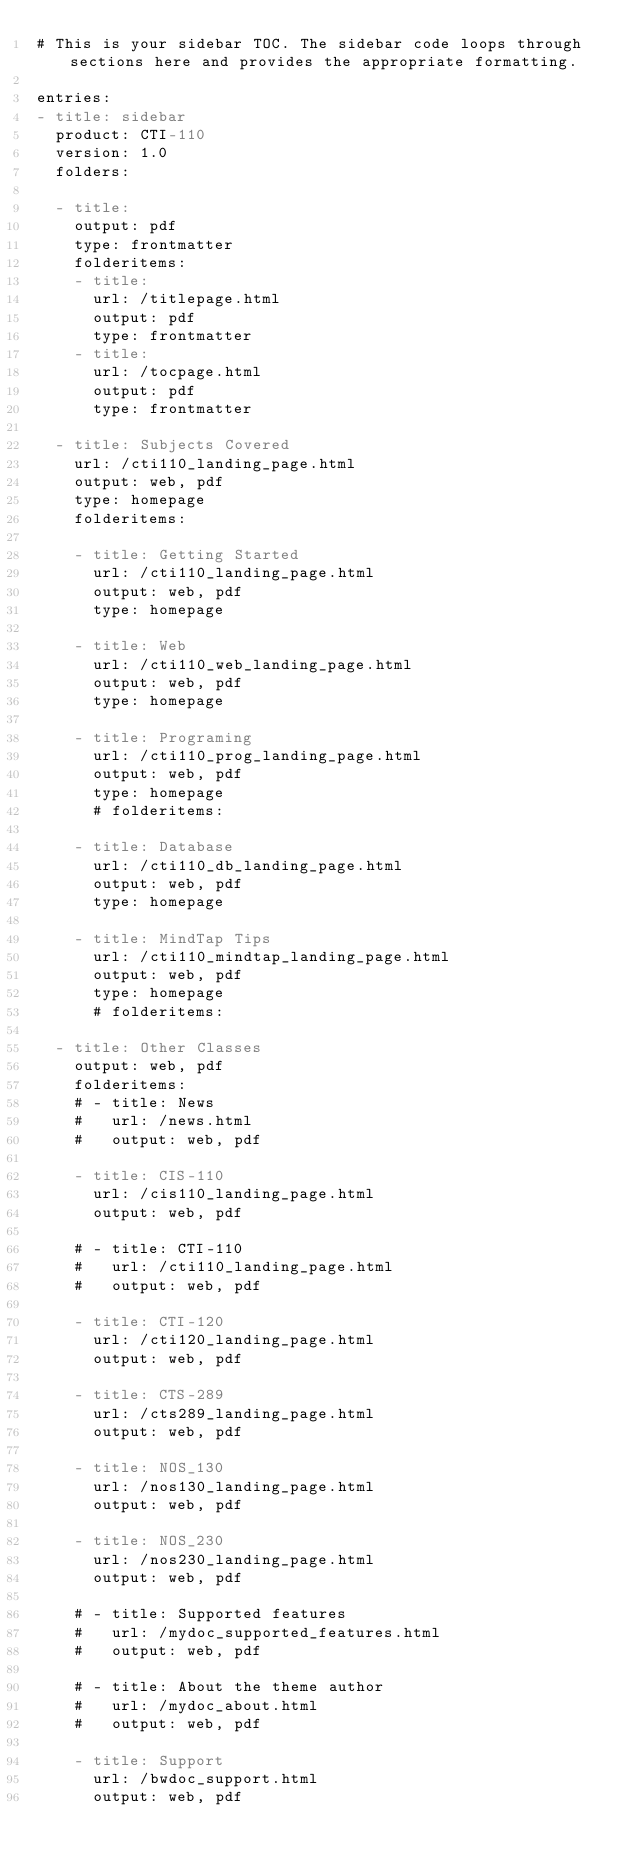Convert code to text. <code><loc_0><loc_0><loc_500><loc_500><_YAML_># This is your sidebar TOC. The sidebar code loops through sections here and provides the appropriate formatting.

entries:
- title: sidebar
  product: CTI-110
  version: 1.0
  folders:

  - title:
    output: pdf
    type: frontmatter
    folderitems:
    - title:
      url: /titlepage.html
      output: pdf
      type: frontmatter
    - title:
      url: /tocpage.html
      output: pdf
      type: frontmatter

  - title: Subjects Covered
    url: /cti110_landing_page.html
    output: web, pdf
    type: homepage
    folderitems:

    - title: Getting Started
      url: /cti110_landing_page.html
      output: web, pdf
      type: homepage

    - title: Web
      url: /cti110_web_landing_page.html
      output: web, pdf
      type: homepage

    - title: Programing
      url: /cti110_prog_landing_page.html
      output: web, pdf
      type: homepage
      # folderitems:

    - title: Database
      url: /cti110_db_landing_page.html
      output: web, pdf
      type: homepage

    - title: MindTap Tips
      url: /cti110_mindtap_landing_page.html
      output: web, pdf
      type: homepage
      # folderitems: 

  - title: Other Classes
    output: web, pdf
    folderitems:
    # - title: News
    #   url: /news.html
    #   output: web, pdf

    - title: CIS-110
      url: /cis110_landing_page.html
      output: web, pdf

    # - title: CTI-110
    #   url: /cti110_landing_page.html
    #   output: web, pdf

    - title: CTI-120
      url: /cti120_landing_page.html
      output: web, pdf

    - title: CTS-289
      url: /cts289_landing_page.html
      output: web, pdf

    - title: NOS_130
      url: /nos130_landing_page.html
      output: web, pdf

    - title: NOS_230
      url: /nos230_landing_page.html
      output: web, pdf

    # - title: Supported features
    #   url: /mydoc_supported_features.html
    #   output: web, pdf

    # - title: About the theme author
    #   url: /mydoc_about.html
    #   output: web, pdf

    - title: Support
      url: /bwdoc_support.html
      output: web, pdf
</code> 